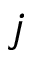Convert formula to latex. <formula><loc_0><loc_0><loc_500><loc_500>j</formula> 